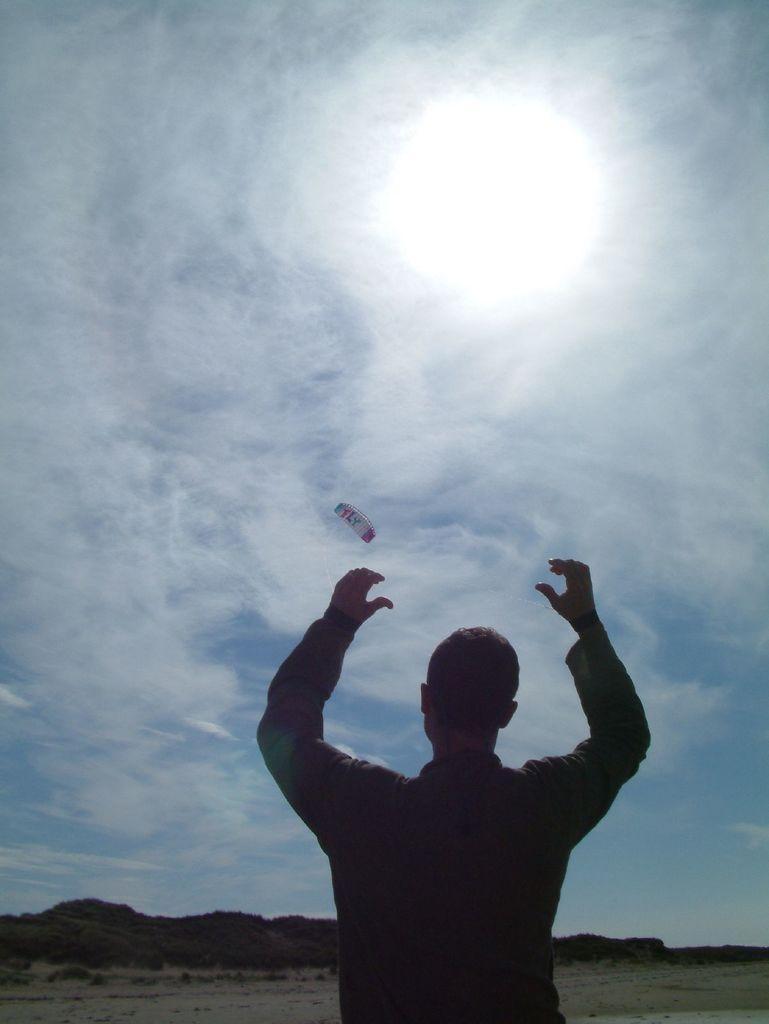Please provide a concise description of this image. In this picture there is a man standing and we can see paragliding in the air. In the background of the image we can see trees and sky with clouds. 